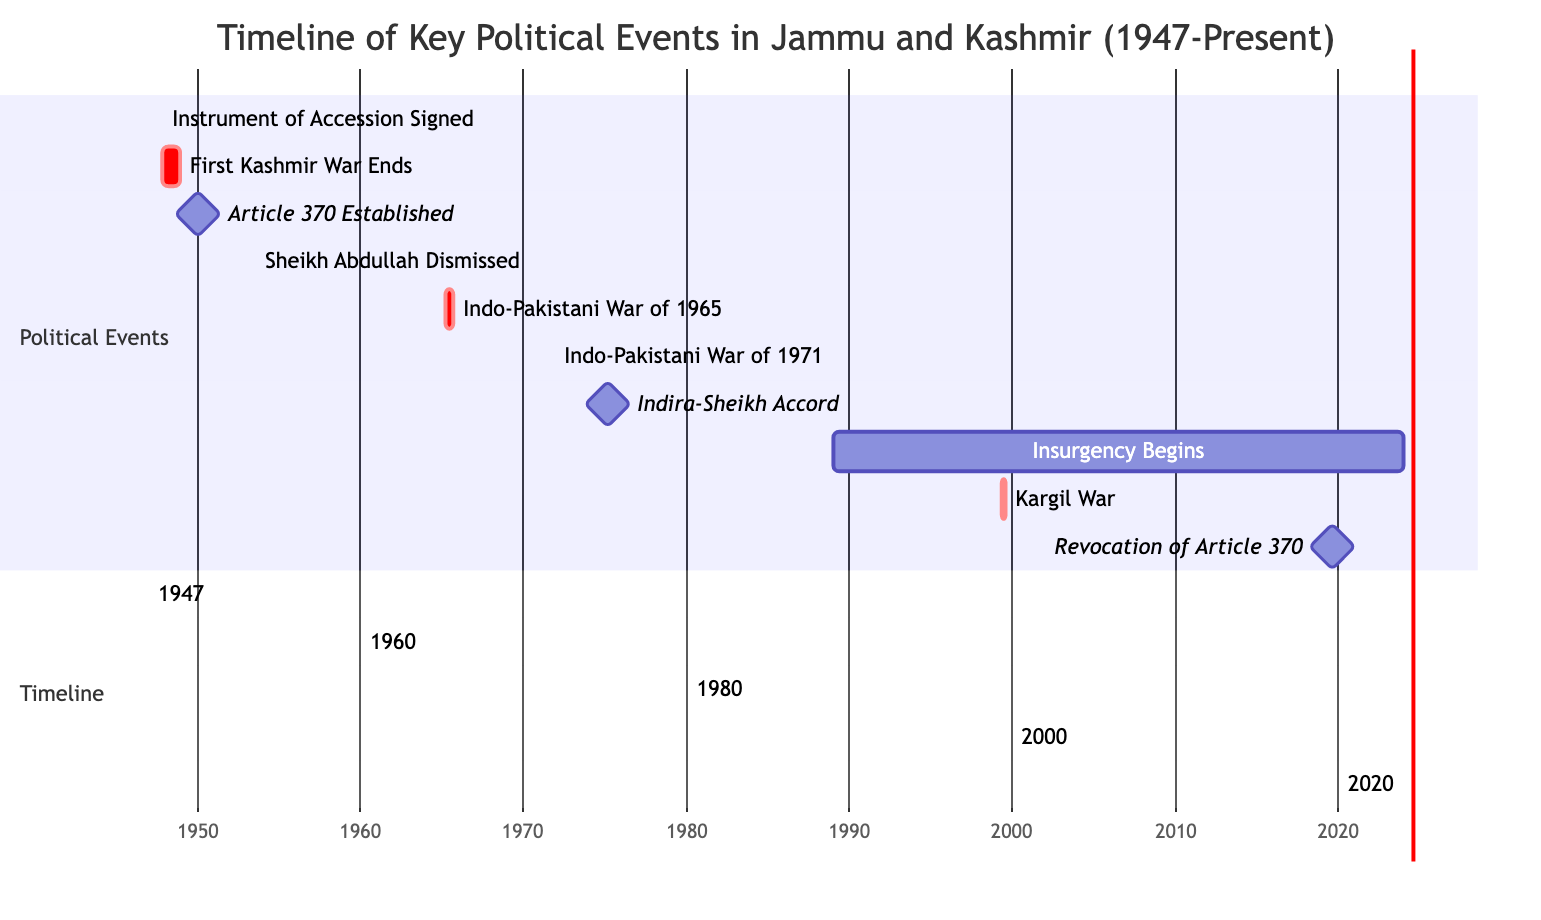What event marks the official integration of Jammu and Kashmir into India? The event that marks the official integration of Jammu and Kashmir into India is the signing of the Instrument of Accession, which is clearly indicated in the timeline of key political events.
Answer: Instrument of Accession Signed Which event took place after the Article 370 was established? The event that took place immediately after Article 370 was established (on January 26, 1950) is Sheikh Abdullah's dismissal, which happened on August 9, 1953. This can be determined by looking at the time order of the events on the Gantt Chart.
Answer: Sheikh Abdullah Dismissed How long did the First Kashmir War last? The First Kashmir War started on October 22, 1947 and ended on January 1, 1949. To calculate its duration, we subtract the start date from the end date. This period amounts to approximately 1 year and a few months.
Answer: 1 year What milestone event occurred on August 5, 2019? The milestone event that occurred on August 5, 2019 is the Revocation of Article 370. This is directly stated in the timeline, highlighting its significance as a major political change.
Answer: Revocation of Article 370 How many major Indo-Pakistani Wars are shown on the Gantt Chart? There are three major Indo-Pakistani Wars illustrated on the Gantt Chart, which can be counted directly from the listed events where each war is distinctly marked. The wars are from 1965, 1971, and the Kargil War in 1999.
Answer: 3 Which event had the longest ongoing impact? The event with the longest ongoing impact is the commencement of the Insurgency, which began on January 1, 1989 and is marked as ongoing in the timeline. This indicates a continuous period of conflict that has not yet concluded.
Answer: Insurgency Begins What significant change did the Indira-Sheikh Accord bring about? The Indira-Sheikh Accord reinstated Sheikh Abdullah as the Chief Minister of Jammu and Kashmir on February 24, 1975, which is the significant change highlighted in the timeline. This information is found in the impact analysis section for that event.
Answer: Reinstated Sheikh Abdullah Which event led to the creation of Bangladesh? The event that led to the creation of Bangladesh is the Indo-Pakistani War of 1971, as mentioned in the impact analysis for that event. This connection is crucial in understanding the broader geopolitical implications of the war.
Answer: Indo-Pakistani War of 1971 What was the impact of the First Kashmir War? The impact of the First Kashmir War included the establishment of the Line of Control and the involvement of the United Nations, as detailed in the impact analysis of that event on the Gantt Chart.
Answer: Established LoC and UN involvement 